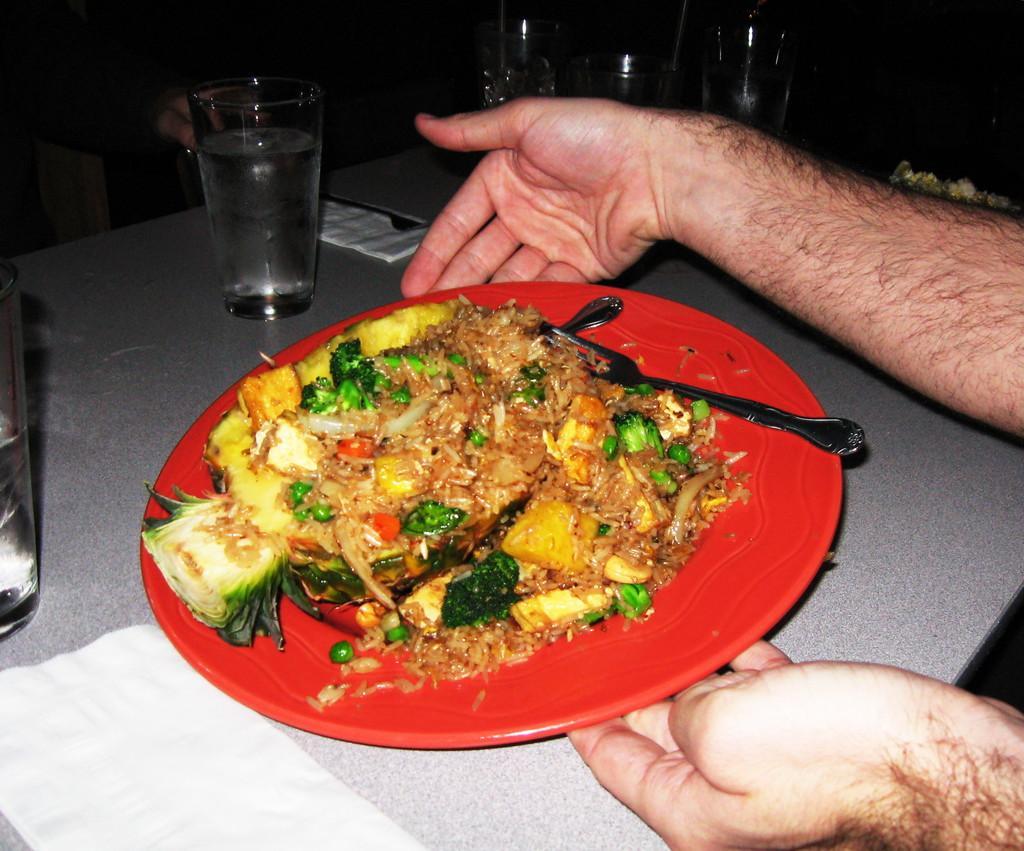Please provide a concise description of this image. This picture shows food in the plate. We see a fork and a spoon. We see a human holding a plate with the hands and we see table and glasses and a jug and few napkins on the table. 